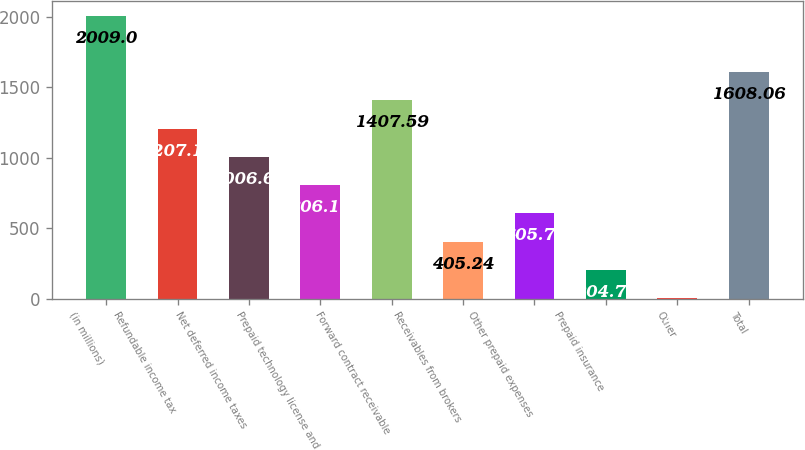<chart> <loc_0><loc_0><loc_500><loc_500><bar_chart><fcel>(in millions)<fcel>Refundable income tax<fcel>Net deferred income taxes<fcel>Prepaid technology license and<fcel>Forward contract receivable<fcel>Receivables from brokers<fcel>Other prepaid expenses<fcel>Prepaid insurance<fcel>Other<fcel>Total<nl><fcel>2009<fcel>1207.12<fcel>1006.65<fcel>806.18<fcel>1407.59<fcel>405.24<fcel>605.71<fcel>204.77<fcel>4.3<fcel>1608.06<nl></chart> 